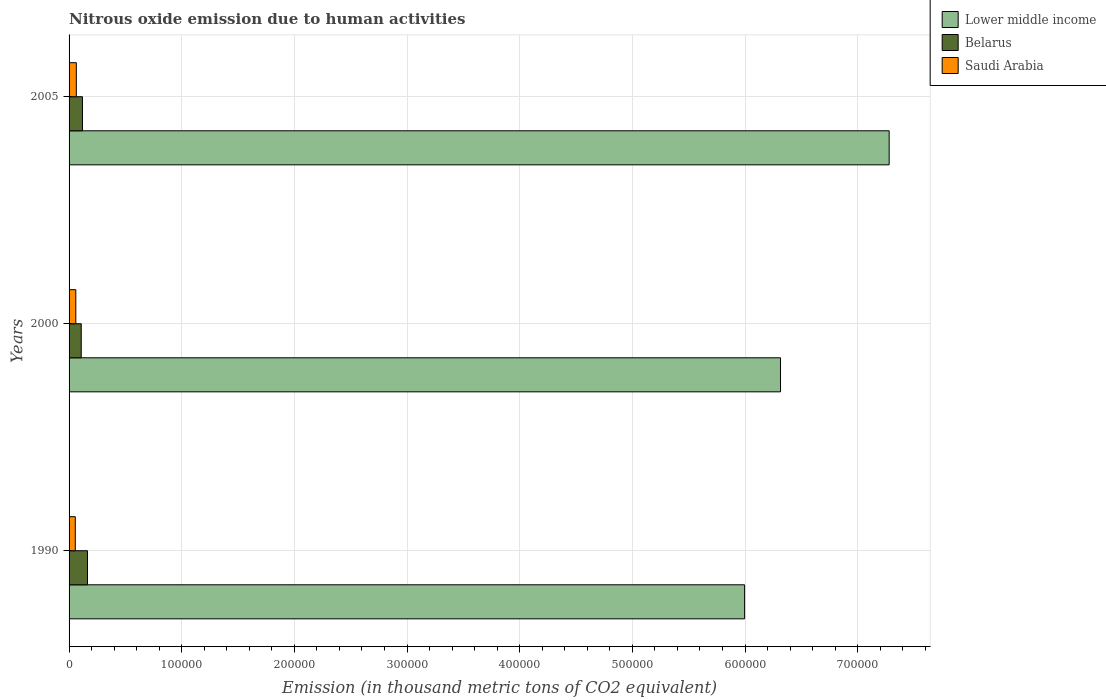Are the number of bars per tick equal to the number of legend labels?
Offer a very short reply. Yes. Are the number of bars on each tick of the Y-axis equal?
Offer a terse response. Yes. How many bars are there on the 2nd tick from the bottom?
Provide a short and direct response. 3. What is the label of the 1st group of bars from the top?
Provide a succinct answer. 2005. What is the amount of nitrous oxide emitted in Belarus in 2005?
Your response must be concise. 1.19e+04. Across all years, what is the maximum amount of nitrous oxide emitted in Belarus?
Offer a terse response. 1.64e+04. Across all years, what is the minimum amount of nitrous oxide emitted in Belarus?
Your answer should be very brief. 1.08e+04. In which year was the amount of nitrous oxide emitted in Lower middle income maximum?
Provide a short and direct response. 2005. In which year was the amount of nitrous oxide emitted in Belarus minimum?
Offer a very short reply. 2000. What is the total amount of nitrous oxide emitted in Saudi Arabia in the graph?
Provide a short and direct response. 1.80e+04. What is the difference between the amount of nitrous oxide emitted in Belarus in 1990 and that in 2005?
Give a very brief answer. 4482.1. What is the difference between the amount of nitrous oxide emitted in Lower middle income in 1990 and the amount of nitrous oxide emitted in Belarus in 2000?
Your response must be concise. 5.89e+05. What is the average amount of nitrous oxide emitted in Lower middle income per year?
Provide a short and direct response. 6.53e+05. In the year 2005, what is the difference between the amount of nitrous oxide emitted in Belarus and amount of nitrous oxide emitted in Lower middle income?
Provide a short and direct response. -7.16e+05. In how many years, is the amount of nitrous oxide emitted in Belarus greater than 100000 thousand metric tons?
Provide a succinct answer. 0. What is the ratio of the amount of nitrous oxide emitted in Lower middle income in 1990 to that in 2005?
Offer a very short reply. 0.82. Is the amount of nitrous oxide emitted in Belarus in 1990 less than that in 2000?
Your answer should be very brief. No. What is the difference between the highest and the second highest amount of nitrous oxide emitted in Saudi Arabia?
Provide a succinct answer. 457.7. What is the difference between the highest and the lowest amount of nitrous oxide emitted in Belarus?
Give a very brief answer. 5576.4. What does the 1st bar from the top in 2000 represents?
Provide a short and direct response. Saudi Arabia. What does the 3rd bar from the bottom in 2000 represents?
Offer a terse response. Saudi Arabia. Is it the case that in every year, the sum of the amount of nitrous oxide emitted in Saudi Arabia and amount of nitrous oxide emitted in Belarus is greater than the amount of nitrous oxide emitted in Lower middle income?
Give a very brief answer. No. How many years are there in the graph?
Give a very brief answer. 3. Are the values on the major ticks of X-axis written in scientific E-notation?
Your answer should be very brief. No. Does the graph contain grids?
Provide a succinct answer. Yes. How many legend labels are there?
Give a very brief answer. 3. How are the legend labels stacked?
Your answer should be very brief. Vertical. What is the title of the graph?
Ensure brevity in your answer.  Nitrous oxide emission due to human activities. What is the label or title of the X-axis?
Give a very brief answer. Emission (in thousand metric tons of CO2 equivalent). What is the label or title of the Y-axis?
Your answer should be compact. Years. What is the Emission (in thousand metric tons of CO2 equivalent) in Lower middle income in 1990?
Your response must be concise. 6.00e+05. What is the Emission (in thousand metric tons of CO2 equivalent) in Belarus in 1990?
Keep it short and to the point. 1.64e+04. What is the Emission (in thousand metric tons of CO2 equivalent) of Saudi Arabia in 1990?
Make the answer very short. 5523.5. What is the Emission (in thousand metric tons of CO2 equivalent) of Lower middle income in 2000?
Offer a very short reply. 6.32e+05. What is the Emission (in thousand metric tons of CO2 equivalent) of Belarus in 2000?
Provide a short and direct response. 1.08e+04. What is the Emission (in thousand metric tons of CO2 equivalent) of Saudi Arabia in 2000?
Provide a short and direct response. 5988.8. What is the Emission (in thousand metric tons of CO2 equivalent) of Lower middle income in 2005?
Give a very brief answer. 7.28e+05. What is the Emission (in thousand metric tons of CO2 equivalent) of Belarus in 2005?
Keep it short and to the point. 1.19e+04. What is the Emission (in thousand metric tons of CO2 equivalent) of Saudi Arabia in 2005?
Keep it short and to the point. 6446.5. Across all years, what is the maximum Emission (in thousand metric tons of CO2 equivalent) of Lower middle income?
Provide a succinct answer. 7.28e+05. Across all years, what is the maximum Emission (in thousand metric tons of CO2 equivalent) in Belarus?
Offer a very short reply. 1.64e+04. Across all years, what is the maximum Emission (in thousand metric tons of CO2 equivalent) of Saudi Arabia?
Make the answer very short. 6446.5. Across all years, what is the minimum Emission (in thousand metric tons of CO2 equivalent) of Lower middle income?
Your answer should be very brief. 6.00e+05. Across all years, what is the minimum Emission (in thousand metric tons of CO2 equivalent) of Belarus?
Offer a very short reply. 1.08e+04. Across all years, what is the minimum Emission (in thousand metric tons of CO2 equivalent) of Saudi Arabia?
Offer a very short reply. 5523.5. What is the total Emission (in thousand metric tons of CO2 equivalent) of Lower middle income in the graph?
Your answer should be very brief. 1.96e+06. What is the total Emission (in thousand metric tons of CO2 equivalent) of Belarus in the graph?
Give a very brief answer. 3.91e+04. What is the total Emission (in thousand metric tons of CO2 equivalent) of Saudi Arabia in the graph?
Provide a succinct answer. 1.80e+04. What is the difference between the Emission (in thousand metric tons of CO2 equivalent) in Lower middle income in 1990 and that in 2000?
Your answer should be compact. -3.19e+04. What is the difference between the Emission (in thousand metric tons of CO2 equivalent) in Belarus in 1990 and that in 2000?
Keep it short and to the point. 5576.4. What is the difference between the Emission (in thousand metric tons of CO2 equivalent) of Saudi Arabia in 1990 and that in 2000?
Offer a very short reply. -465.3. What is the difference between the Emission (in thousand metric tons of CO2 equivalent) of Lower middle income in 1990 and that in 2005?
Provide a succinct answer. -1.28e+05. What is the difference between the Emission (in thousand metric tons of CO2 equivalent) of Belarus in 1990 and that in 2005?
Provide a short and direct response. 4482.1. What is the difference between the Emission (in thousand metric tons of CO2 equivalent) of Saudi Arabia in 1990 and that in 2005?
Keep it short and to the point. -923. What is the difference between the Emission (in thousand metric tons of CO2 equivalent) in Lower middle income in 2000 and that in 2005?
Ensure brevity in your answer.  -9.64e+04. What is the difference between the Emission (in thousand metric tons of CO2 equivalent) in Belarus in 2000 and that in 2005?
Provide a short and direct response. -1094.3. What is the difference between the Emission (in thousand metric tons of CO2 equivalent) of Saudi Arabia in 2000 and that in 2005?
Your answer should be compact. -457.7. What is the difference between the Emission (in thousand metric tons of CO2 equivalent) of Lower middle income in 1990 and the Emission (in thousand metric tons of CO2 equivalent) of Belarus in 2000?
Your answer should be compact. 5.89e+05. What is the difference between the Emission (in thousand metric tons of CO2 equivalent) of Lower middle income in 1990 and the Emission (in thousand metric tons of CO2 equivalent) of Saudi Arabia in 2000?
Make the answer very short. 5.94e+05. What is the difference between the Emission (in thousand metric tons of CO2 equivalent) in Belarus in 1990 and the Emission (in thousand metric tons of CO2 equivalent) in Saudi Arabia in 2000?
Give a very brief answer. 1.04e+04. What is the difference between the Emission (in thousand metric tons of CO2 equivalent) of Lower middle income in 1990 and the Emission (in thousand metric tons of CO2 equivalent) of Belarus in 2005?
Provide a succinct answer. 5.88e+05. What is the difference between the Emission (in thousand metric tons of CO2 equivalent) of Lower middle income in 1990 and the Emission (in thousand metric tons of CO2 equivalent) of Saudi Arabia in 2005?
Your response must be concise. 5.93e+05. What is the difference between the Emission (in thousand metric tons of CO2 equivalent) in Belarus in 1990 and the Emission (in thousand metric tons of CO2 equivalent) in Saudi Arabia in 2005?
Your answer should be compact. 9925.8. What is the difference between the Emission (in thousand metric tons of CO2 equivalent) of Lower middle income in 2000 and the Emission (in thousand metric tons of CO2 equivalent) of Belarus in 2005?
Provide a succinct answer. 6.20e+05. What is the difference between the Emission (in thousand metric tons of CO2 equivalent) of Lower middle income in 2000 and the Emission (in thousand metric tons of CO2 equivalent) of Saudi Arabia in 2005?
Offer a terse response. 6.25e+05. What is the difference between the Emission (in thousand metric tons of CO2 equivalent) of Belarus in 2000 and the Emission (in thousand metric tons of CO2 equivalent) of Saudi Arabia in 2005?
Make the answer very short. 4349.4. What is the average Emission (in thousand metric tons of CO2 equivalent) of Lower middle income per year?
Ensure brevity in your answer.  6.53e+05. What is the average Emission (in thousand metric tons of CO2 equivalent) of Belarus per year?
Ensure brevity in your answer.  1.30e+04. What is the average Emission (in thousand metric tons of CO2 equivalent) of Saudi Arabia per year?
Offer a terse response. 5986.27. In the year 1990, what is the difference between the Emission (in thousand metric tons of CO2 equivalent) of Lower middle income and Emission (in thousand metric tons of CO2 equivalent) of Belarus?
Your response must be concise. 5.83e+05. In the year 1990, what is the difference between the Emission (in thousand metric tons of CO2 equivalent) in Lower middle income and Emission (in thousand metric tons of CO2 equivalent) in Saudi Arabia?
Ensure brevity in your answer.  5.94e+05. In the year 1990, what is the difference between the Emission (in thousand metric tons of CO2 equivalent) of Belarus and Emission (in thousand metric tons of CO2 equivalent) of Saudi Arabia?
Provide a succinct answer. 1.08e+04. In the year 2000, what is the difference between the Emission (in thousand metric tons of CO2 equivalent) in Lower middle income and Emission (in thousand metric tons of CO2 equivalent) in Belarus?
Your response must be concise. 6.21e+05. In the year 2000, what is the difference between the Emission (in thousand metric tons of CO2 equivalent) in Lower middle income and Emission (in thousand metric tons of CO2 equivalent) in Saudi Arabia?
Your answer should be compact. 6.26e+05. In the year 2000, what is the difference between the Emission (in thousand metric tons of CO2 equivalent) in Belarus and Emission (in thousand metric tons of CO2 equivalent) in Saudi Arabia?
Offer a very short reply. 4807.1. In the year 2005, what is the difference between the Emission (in thousand metric tons of CO2 equivalent) of Lower middle income and Emission (in thousand metric tons of CO2 equivalent) of Belarus?
Offer a very short reply. 7.16e+05. In the year 2005, what is the difference between the Emission (in thousand metric tons of CO2 equivalent) of Lower middle income and Emission (in thousand metric tons of CO2 equivalent) of Saudi Arabia?
Your answer should be compact. 7.22e+05. In the year 2005, what is the difference between the Emission (in thousand metric tons of CO2 equivalent) of Belarus and Emission (in thousand metric tons of CO2 equivalent) of Saudi Arabia?
Your answer should be very brief. 5443.7. What is the ratio of the Emission (in thousand metric tons of CO2 equivalent) of Lower middle income in 1990 to that in 2000?
Provide a succinct answer. 0.95. What is the ratio of the Emission (in thousand metric tons of CO2 equivalent) of Belarus in 1990 to that in 2000?
Make the answer very short. 1.52. What is the ratio of the Emission (in thousand metric tons of CO2 equivalent) of Saudi Arabia in 1990 to that in 2000?
Offer a very short reply. 0.92. What is the ratio of the Emission (in thousand metric tons of CO2 equivalent) in Lower middle income in 1990 to that in 2005?
Give a very brief answer. 0.82. What is the ratio of the Emission (in thousand metric tons of CO2 equivalent) in Belarus in 1990 to that in 2005?
Ensure brevity in your answer.  1.38. What is the ratio of the Emission (in thousand metric tons of CO2 equivalent) of Saudi Arabia in 1990 to that in 2005?
Offer a very short reply. 0.86. What is the ratio of the Emission (in thousand metric tons of CO2 equivalent) of Lower middle income in 2000 to that in 2005?
Your response must be concise. 0.87. What is the ratio of the Emission (in thousand metric tons of CO2 equivalent) of Belarus in 2000 to that in 2005?
Provide a succinct answer. 0.91. What is the ratio of the Emission (in thousand metric tons of CO2 equivalent) in Saudi Arabia in 2000 to that in 2005?
Offer a terse response. 0.93. What is the difference between the highest and the second highest Emission (in thousand metric tons of CO2 equivalent) in Lower middle income?
Provide a short and direct response. 9.64e+04. What is the difference between the highest and the second highest Emission (in thousand metric tons of CO2 equivalent) of Belarus?
Offer a terse response. 4482.1. What is the difference between the highest and the second highest Emission (in thousand metric tons of CO2 equivalent) of Saudi Arabia?
Provide a succinct answer. 457.7. What is the difference between the highest and the lowest Emission (in thousand metric tons of CO2 equivalent) in Lower middle income?
Keep it short and to the point. 1.28e+05. What is the difference between the highest and the lowest Emission (in thousand metric tons of CO2 equivalent) in Belarus?
Offer a very short reply. 5576.4. What is the difference between the highest and the lowest Emission (in thousand metric tons of CO2 equivalent) of Saudi Arabia?
Your answer should be compact. 923. 